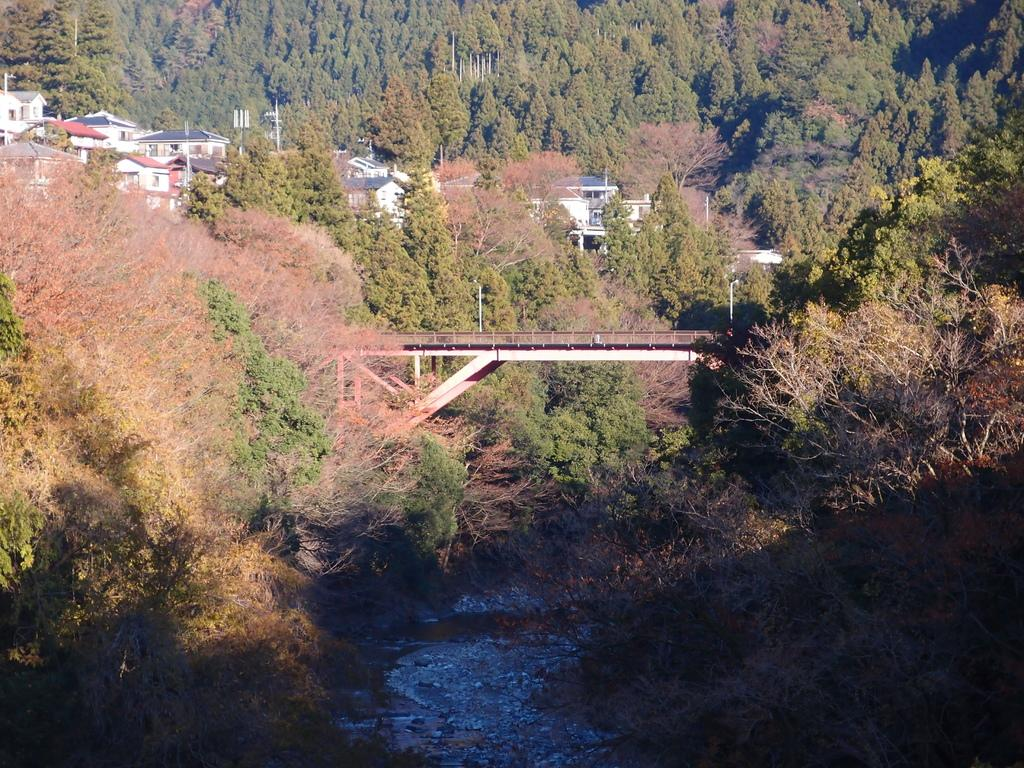What is at the bottom of the image? There is water at the bottom of the image. What structure can be seen in the middle of the image? There is a bridge in the middle of the image. What type of natural environment is visible in the background of the image? There are many trees in the background of the image. What type of man-made structures can be seen in the background of the image? There are buildings in the background of the image. How many legs does the spoon have in the image? There is no spoon present in the image. What historical event is depicted in the image? The image does not depict any historical event; it features a bridge, water, trees, and buildings. 